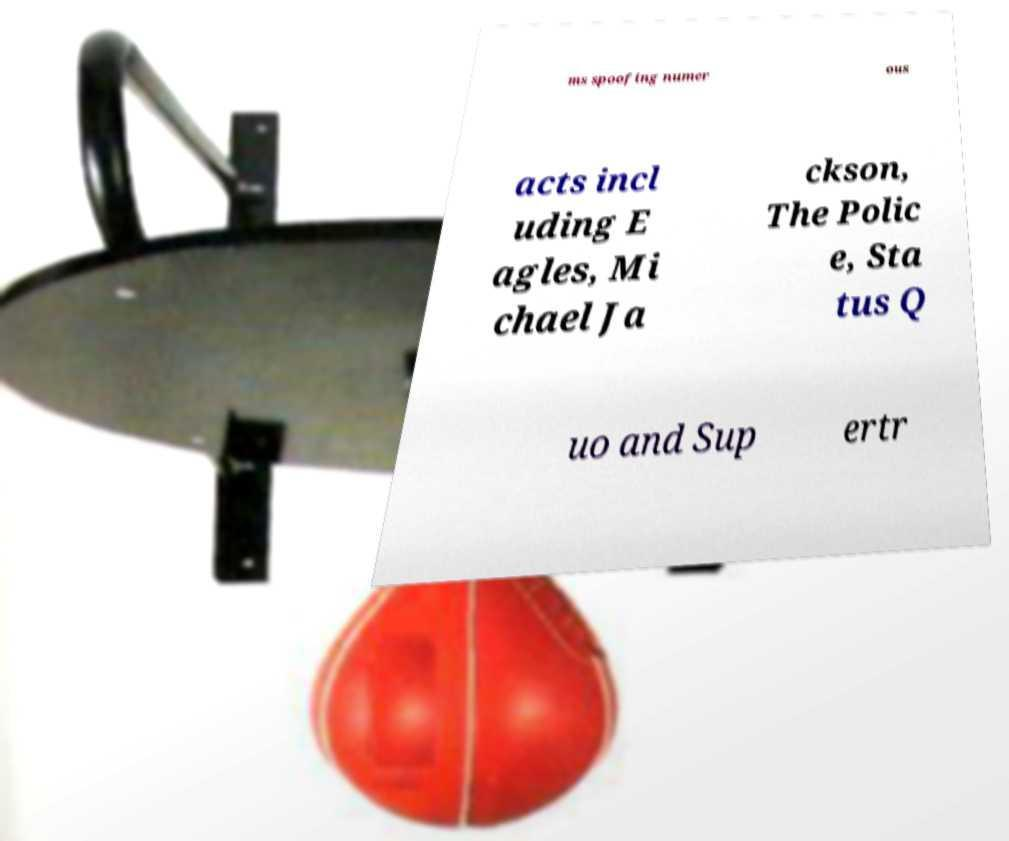I need the written content from this picture converted into text. Can you do that? ms spoofing numer ous acts incl uding E agles, Mi chael Ja ckson, The Polic e, Sta tus Q uo and Sup ertr 